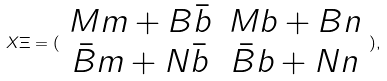<formula> <loc_0><loc_0><loc_500><loc_500>X \Xi = ( \begin{array} { c c } M m + B \bar { b } & M b + B n \\ \bar { B } m + N \bar { b } & \bar { B } b + N n \end{array} ) ,</formula> 